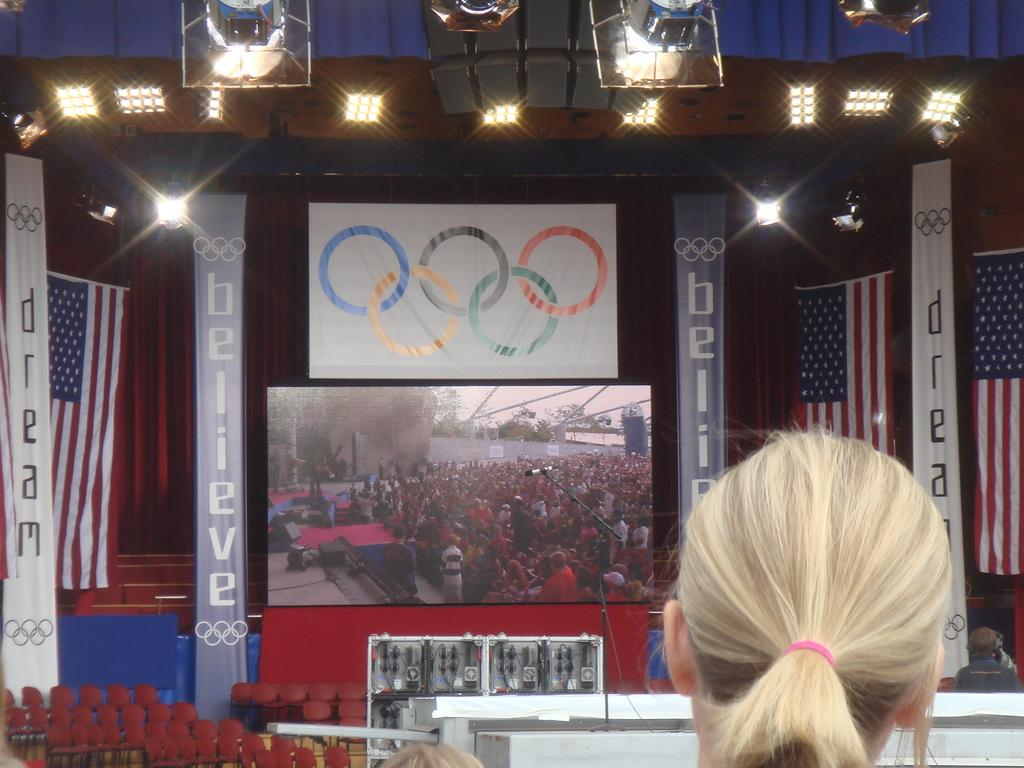What type of display is present in the image? There is a led display in the image. What can be seen illuminated in the image? There are lights visible in the image. What national symbols are present in the image? There are flags in the image. What type of seating is available in the image? There are chairs in the image. What type of decorations are hanging in the image? There are banners hanging in the image. Who is present in the image? There is a woman standing in the image. What type of dress is the woman wearing in the image? The provided facts do not mention the woman's attire, so we cannot determine the type of dress she is wearing. Is there any oil visible in the image? There is no mention of oil in the provided facts, so we cannot determine if it is present in the image. 